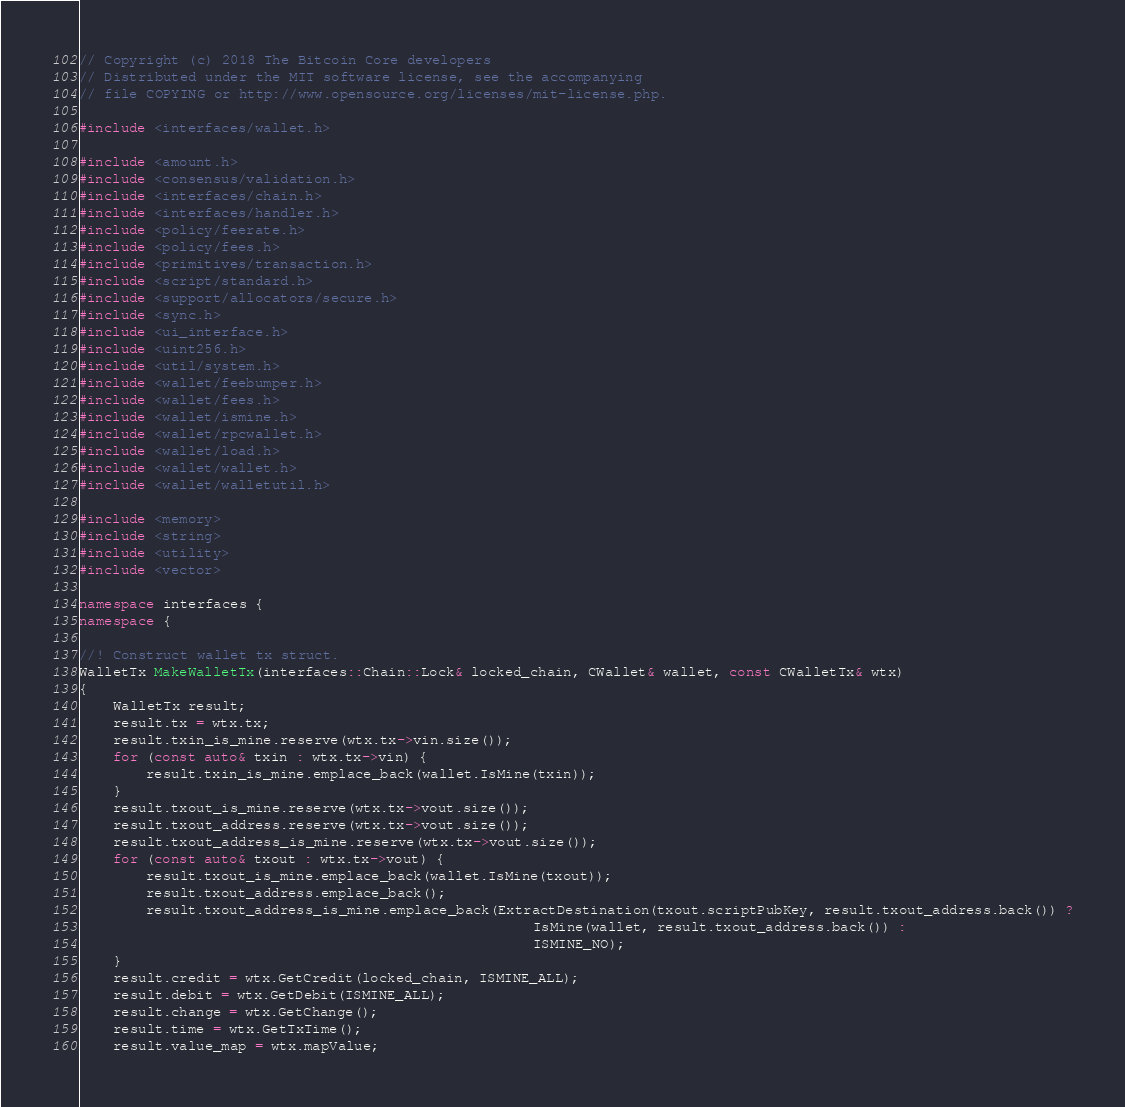Convert code to text. <code><loc_0><loc_0><loc_500><loc_500><_C++_>// Copyright (c) 2018 The Bitcoin Core developers
// Distributed under the MIT software license, see the accompanying
// file COPYING or http://www.opensource.org/licenses/mit-license.php.

#include <interfaces/wallet.h>

#include <amount.h>
#include <consensus/validation.h>
#include <interfaces/chain.h>
#include <interfaces/handler.h>
#include <policy/feerate.h>
#include <policy/fees.h>
#include <primitives/transaction.h>
#include <script/standard.h>
#include <support/allocators/secure.h>
#include <sync.h>
#include <ui_interface.h>
#include <uint256.h>
#include <util/system.h>
#include <wallet/feebumper.h>
#include <wallet/fees.h>
#include <wallet/ismine.h>
#include <wallet/rpcwallet.h>
#include <wallet/load.h>
#include <wallet/wallet.h>
#include <wallet/walletutil.h>

#include <memory>
#include <string>
#include <utility>
#include <vector>

namespace interfaces {
namespace {

//! Construct wallet tx struct.
WalletTx MakeWalletTx(interfaces::Chain::Lock& locked_chain, CWallet& wallet, const CWalletTx& wtx)
{
    WalletTx result;
    result.tx = wtx.tx;
    result.txin_is_mine.reserve(wtx.tx->vin.size());
    for (const auto& txin : wtx.tx->vin) {
        result.txin_is_mine.emplace_back(wallet.IsMine(txin));
    }
    result.txout_is_mine.reserve(wtx.tx->vout.size());
    result.txout_address.reserve(wtx.tx->vout.size());
    result.txout_address_is_mine.reserve(wtx.tx->vout.size());
    for (const auto& txout : wtx.tx->vout) {
        result.txout_is_mine.emplace_back(wallet.IsMine(txout));
        result.txout_address.emplace_back();
        result.txout_address_is_mine.emplace_back(ExtractDestination(txout.scriptPubKey, result.txout_address.back()) ?
                                                      IsMine(wallet, result.txout_address.back()) :
                                                      ISMINE_NO);
    }
    result.credit = wtx.GetCredit(locked_chain, ISMINE_ALL);
    result.debit = wtx.GetDebit(ISMINE_ALL);
    result.change = wtx.GetChange();
    result.time = wtx.GetTxTime();
    result.value_map = wtx.mapValue;</code> 